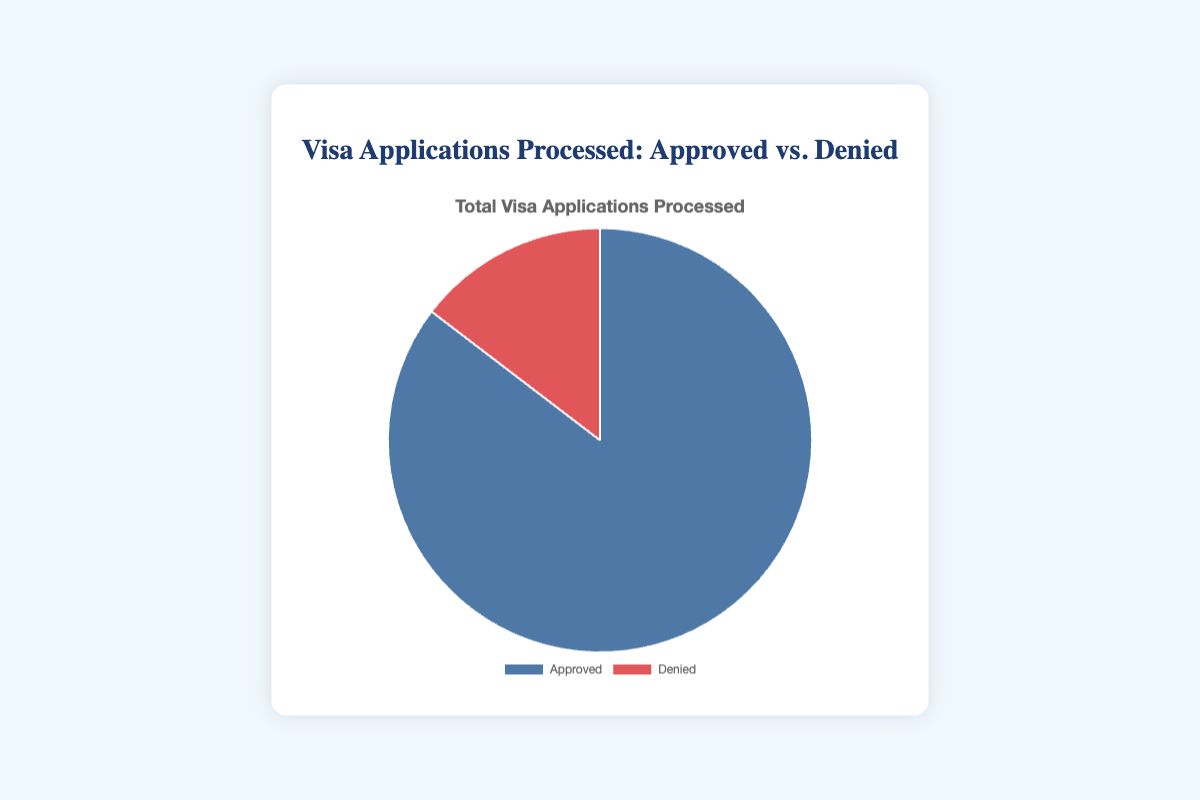What percentage of visa applications were denied? The total number of visa applications is the sum of approved and denied applications, which is 55500 + 9500 = 65000. The percentage denied is (9500 / 65000) * 100.
Answer: 14.62% Which category has a higher number of applications, Approved or Denied? The chart shows that there are 55500 approved applications and 9500 denied applications. Comparing these two numbers, approved applications are higher.
Answer: Approved What is the difference between approved and denied visa applications? Subtract the number of denied applications from the number of approved applications: 55500 - 9500.
Answer: 46000 What proportion of the total applications does the approved category represent? The total number of applications is 65000. The approved applications are 55500. The proportion is 55500 / 65000.
Answer: 0.854 (or 85.4%) If the denied applications increased by 1000, what would the new percentage of denied applications be? New denied applications would be 9500 + 1000 = 10500. The new total applications would be 55500 + 10500 = 66000. The percentage is (10500 / 66000) * 100.
Answer: 15.91% How many more applications were approved than denied for Canada? Canada's approved applications are 12000 and denied applications are 2000. The difference is 12000 - 2000.
Answer: 10000 Which segment on the pie chart is larger, the blue one or the red one? The chart's blue segment represents approved applications, and the red one represents denied applications. The blue segment is larger since it represents 55500 applications compared to 9500 for the red segment.
Answer: Blue What is the combined total number of visa applications processed by the United States and Canada? Add the total applications processed by the United States (15000 + 3000) and Canada (12000 + 2000).
Answer: 32000 Which country processed the least number of visa applications overall? Calculate the total applications for each country: United States (18000), United Kingdom (10000), Canada (14000), Germany (12200), Australia (10800). The United Kingdom processed the least.
Answer: United Kingdom What is the sum of visa applications approved for the United States and Germany? Add the number of approved applications for the United States (15000) and Germany (10500).
Answer: 25500 